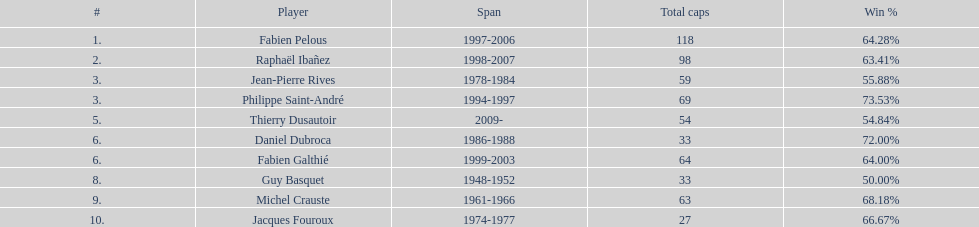Which captain served the least amount of time? Daniel Dubroca. 